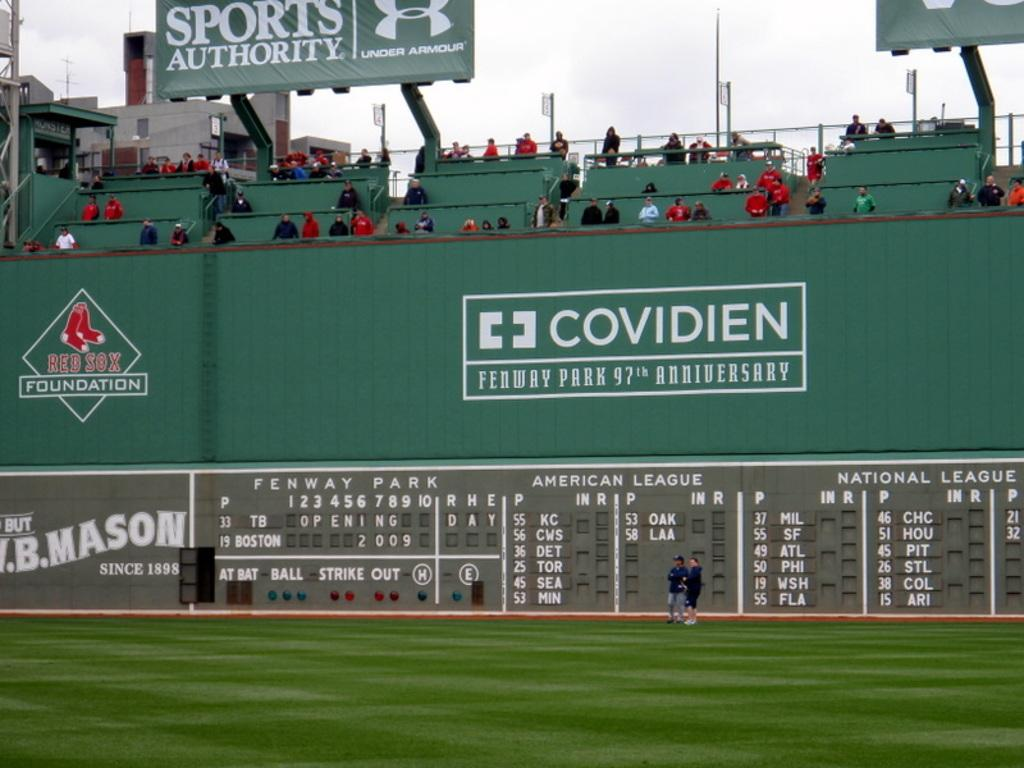<image>
Create a compact narrative representing the image presented. Baseball stadium with an ad for Sports Authority behind. 